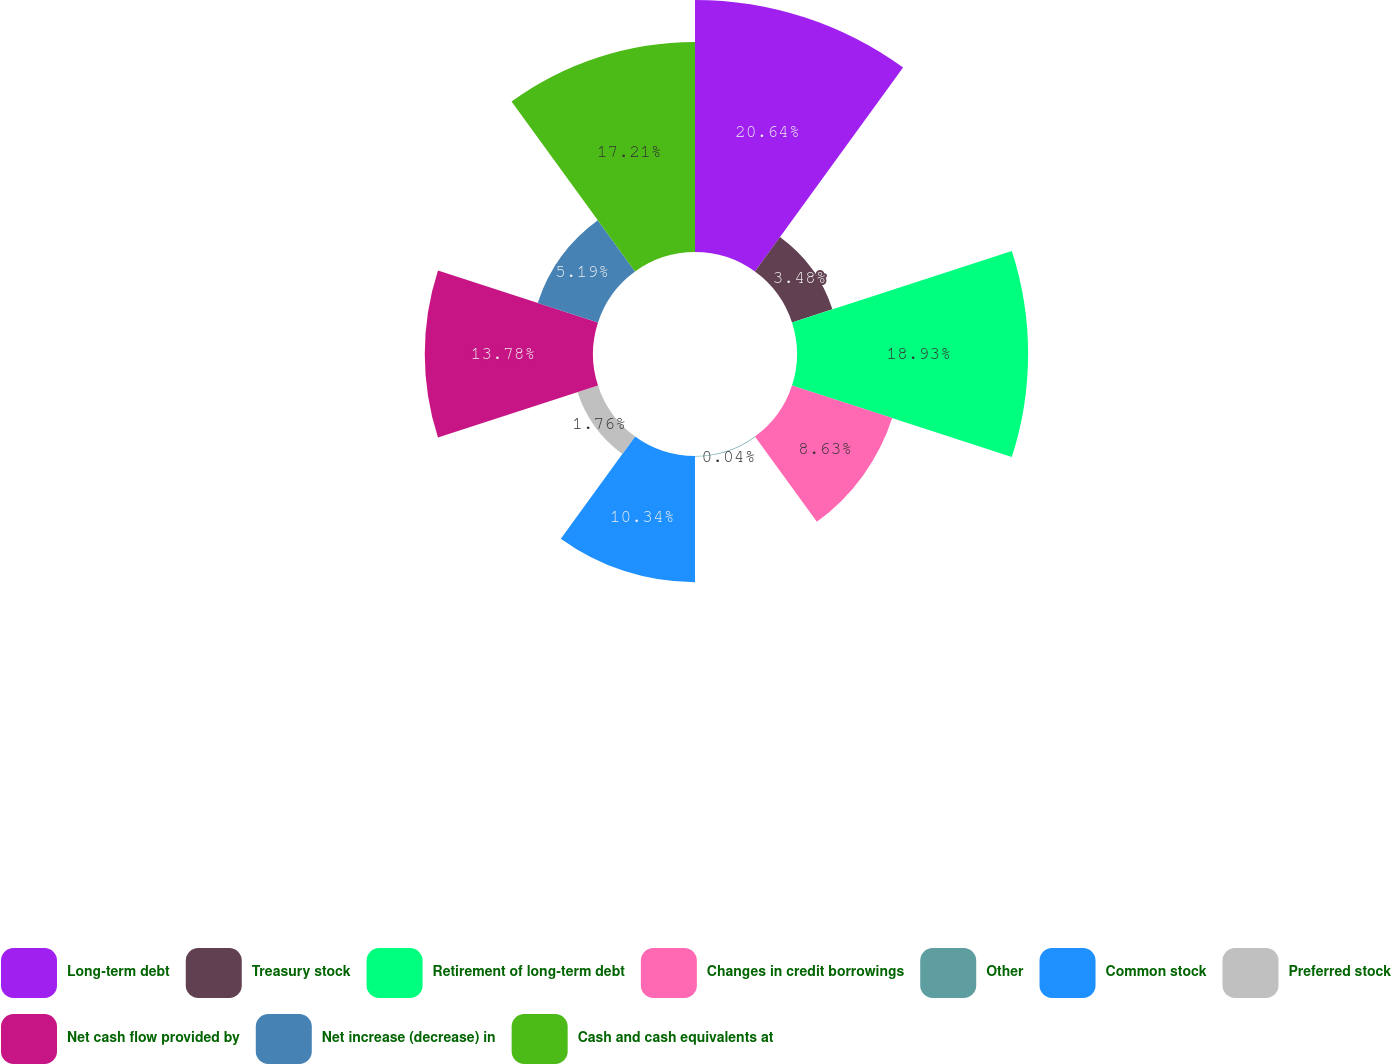Convert chart to OTSL. <chart><loc_0><loc_0><loc_500><loc_500><pie_chart><fcel>Long-term debt<fcel>Treasury stock<fcel>Retirement of long-term debt<fcel>Changes in credit borrowings<fcel>Other<fcel>Common stock<fcel>Preferred stock<fcel>Net cash flow provided by<fcel>Net increase (decrease) in<fcel>Cash and cash equivalents at<nl><fcel>20.64%<fcel>3.48%<fcel>18.93%<fcel>8.63%<fcel>0.04%<fcel>10.34%<fcel>1.76%<fcel>13.78%<fcel>5.19%<fcel>17.21%<nl></chart> 